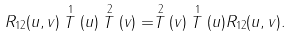<formula> <loc_0><loc_0><loc_500><loc_500>R _ { 1 2 } ( u , v ) \stackrel { 1 } { T } ( u ) \stackrel { 2 } { T } ( v ) = \stackrel { 2 } { T } ( v ) \stackrel { 1 } { T } ( u ) R _ { 1 2 } ( u , v ) .</formula> 